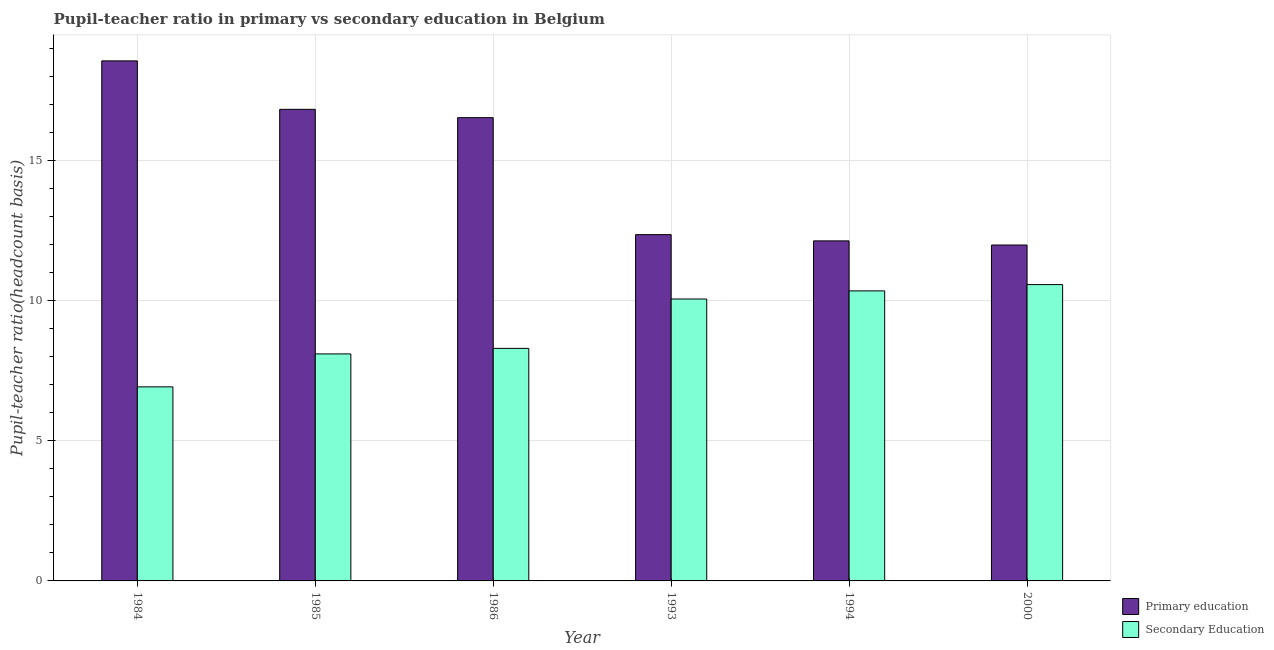How many different coloured bars are there?
Keep it short and to the point. 2. Are the number of bars on each tick of the X-axis equal?
Make the answer very short. Yes. How many bars are there on the 3rd tick from the left?
Your response must be concise. 2. What is the label of the 1st group of bars from the left?
Give a very brief answer. 1984. In how many cases, is the number of bars for a given year not equal to the number of legend labels?
Your answer should be very brief. 0. What is the pupil-teacher ratio in primary education in 1986?
Your answer should be compact. 16.53. Across all years, what is the maximum pupil teacher ratio on secondary education?
Your answer should be compact. 10.57. Across all years, what is the minimum pupil-teacher ratio in primary education?
Ensure brevity in your answer.  11.98. In which year was the pupil-teacher ratio in primary education maximum?
Ensure brevity in your answer.  1984. What is the total pupil teacher ratio on secondary education in the graph?
Provide a succinct answer. 54.29. What is the difference between the pupil teacher ratio on secondary education in 1985 and that in 1986?
Ensure brevity in your answer.  -0.2. What is the difference between the pupil teacher ratio on secondary education in 1985 and the pupil-teacher ratio in primary education in 1993?
Your answer should be compact. -1.96. What is the average pupil teacher ratio on secondary education per year?
Keep it short and to the point. 9.05. In how many years, is the pupil-teacher ratio in primary education greater than 6?
Keep it short and to the point. 6. What is the ratio of the pupil teacher ratio on secondary education in 1985 to that in 1994?
Keep it short and to the point. 0.78. Is the pupil teacher ratio on secondary education in 1985 less than that in 1994?
Keep it short and to the point. Yes. Is the difference between the pupil-teacher ratio in primary education in 1986 and 1994 greater than the difference between the pupil teacher ratio on secondary education in 1986 and 1994?
Your answer should be very brief. No. What is the difference between the highest and the second highest pupil-teacher ratio in primary education?
Your response must be concise. 1.73. What is the difference between the highest and the lowest pupil-teacher ratio in primary education?
Give a very brief answer. 6.57. In how many years, is the pupil-teacher ratio in primary education greater than the average pupil-teacher ratio in primary education taken over all years?
Your answer should be very brief. 3. Is the sum of the pupil-teacher ratio in primary education in 1986 and 1993 greater than the maximum pupil teacher ratio on secondary education across all years?
Your response must be concise. Yes. What does the 2nd bar from the left in 1984 represents?
Your answer should be compact. Secondary Education. Are all the bars in the graph horizontal?
Provide a short and direct response. No. How many years are there in the graph?
Give a very brief answer. 6. Are the values on the major ticks of Y-axis written in scientific E-notation?
Offer a very short reply. No. Does the graph contain grids?
Keep it short and to the point. Yes. How many legend labels are there?
Provide a short and direct response. 2. What is the title of the graph?
Provide a succinct answer. Pupil-teacher ratio in primary vs secondary education in Belgium. Does "Current US$" appear as one of the legend labels in the graph?
Make the answer very short. No. What is the label or title of the Y-axis?
Make the answer very short. Pupil-teacher ratio(headcount basis). What is the Pupil-teacher ratio(headcount basis) in Primary education in 1984?
Ensure brevity in your answer.  18.55. What is the Pupil-teacher ratio(headcount basis) of Secondary Education in 1984?
Make the answer very short. 6.92. What is the Pupil-teacher ratio(headcount basis) of Primary education in 1985?
Offer a terse response. 16.82. What is the Pupil-teacher ratio(headcount basis) in Secondary Education in 1985?
Provide a short and direct response. 8.1. What is the Pupil-teacher ratio(headcount basis) of Primary education in 1986?
Offer a very short reply. 16.53. What is the Pupil-teacher ratio(headcount basis) in Secondary Education in 1986?
Provide a short and direct response. 8.3. What is the Pupil-teacher ratio(headcount basis) in Primary education in 1993?
Your answer should be very brief. 12.35. What is the Pupil-teacher ratio(headcount basis) of Secondary Education in 1993?
Provide a succinct answer. 10.06. What is the Pupil-teacher ratio(headcount basis) in Primary education in 1994?
Offer a terse response. 12.13. What is the Pupil-teacher ratio(headcount basis) of Secondary Education in 1994?
Keep it short and to the point. 10.35. What is the Pupil-teacher ratio(headcount basis) in Primary education in 2000?
Your response must be concise. 11.98. What is the Pupil-teacher ratio(headcount basis) in Secondary Education in 2000?
Keep it short and to the point. 10.57. Across all years, what is the maximum Pupil-teacher ratio(headcount basis) in Primary education?
Your answer should be compact. 18.55. Across all years, what is the maximum Pupil-teacher ratio(headcount basis) of Secondary Education?
Your answer should be very brief. 10.57. Across all years, what is the minimum Pupil-teacher ratio(headcount basis) of Primary education?
Your answer should be compact. 11.98. Across all years, what is the minimum Pupil-teacher ratio(headcount basis) in Secondary Education?
Ensure brevity in your answer.  6.92. What is the total Pupil-teacher ratio(headcount basis) of Primary education in the graph?
Offer a very short reply. 88.37. What is the total Pupil-teacher ratio(headcount basis) of Secondary Education in the graph?
Offer a terse response. 54.29. What is the difference between the Pupil-teacher ratio(headcount basis) in Primary education in 1984 and that in 1985?
Your answer should be compact. 1.73. What is the difference between the Pupil-teacher ratio(headcount basis) in Secondary Education in 1984 and that in 1985?
Give a very brief answer. -1.18. What is the difference between the Pupil-teacher ratio(headcount basis) in Primary education in 1984 and that in 1986?
Your answer should be compact. 2.03. What is the difference between the Pupil-teacher ratio(headcount basis) of Secondary Education in 1984 and that in 1986?
Your answer should be very brief. -1.37. What is the difference between the Pupil-teacher ratio(headcount basis) in Primary education in 1984 and that in 1993?
Offer a terse response. 6.2. What is the difference between the Pupil-teacher ratio(headcount basis) in Secondary Education in 1984 and that in 1993?
Provide a succinct answer. -3.13. What is the difference between the Pupil-teacher ratio(headcount basis) in Primary education in 1984 and that in 1994?
Give a very brief answer. 6.42. What is the difference between the Pupil-teacher ratio(headcount basis) in Secondary Education in 1984 and that in 1994?
Your answer should be very brief. -3.42. What is the difference between the Pupil-teacher ratio(headcount basis) in Primary education in 1984 and that in 2000?
Ensure brevity in your answer.  6.57. What is the difference between the Pupil-teacher ratio(headcount basis) in Secondary Education in 1984 and that in 2000?
Keep it short and to the point. -3.65. What is the difference between the Pupil-teacher ratio(headcount basis) in Primary education in 1985 and that in 1986?
Keep it short and to the point. 0.3. What is the difference between the Pupil-teacher ratio(headcount basis) of Secondary Education in 1985 and that in 1986?
Give a very brief answer. -0.2. What is the difference between the Pupil-teacher ratio(headcount basis) in Primary education in 1985 and that in 1993?
Ensure brevity in your answer.  4.47. What is the difference between the Pupil-teacher ratio(headcount basis) of Secondary Education in 1985 and that in 1993?
Your response must be concise. -1.96. What is the difference between the Pupil-teacher ratio(headcount basis) of Primary education in 1985 and that in 1994?
Keep it short and to the point. 4.69. What is the difference between the Pupil-teacher ratio(headcount basis) of Secondary Education in 1985 and that in 1994?
Offer a very short reply. -2.25. What is the difference between the Pupil-teacher ratio(headcount basis) in Primary education in 1985 and that in 2000?
Make the answer very short. 4.84. What is the difference between the Pupil-teacher ratio(headcount basis) in Secondary Education in 1985 and that in 2000?
Ensure brevity in your answer.  -2.47. What is the difference between the Pupil-teacher ratio(headcount basis) in Primary education in 1986 and that in 1993?
Your answer should be compact. 4.17. What is the difference between the Pupil-teacher ratio(headcount basis) in Secondary Education in 1986 and that in 1993?
Your answer should be very brief. -1.76. What is the difference between the Pupil-teacher ratio(headcount basis) in Primary education in 1986 and that in 1994?
Make the answer very short. 4.4. What is the difference between the Pupil-teacher ratio(headcount basis) of Secondary Education in 1986 and that in 1994?
Offer a very short reply. -2.05. What is the difference between the Pupil-teacher ratio(headcount basis) of Primary education in 1986 and that in 2000?
Your answer should be compact. 4.54. What is the difference between the Pupil-teacher ratio(headcount basis) of Secondary Education in 1986 and that in 2000?
Offer a very short reply. -2.27. What is the difference between the Pupil-teacher ratio(headcount basis) in Primary education in 1993 and that in 1994?
Your response must be concise. 0.22. What is the difference between the Pupil-teacher ratio(headcount basis) in Secondary Education in 1993 and that in 1994?
Your response must be concise. -0.29. What is the difference between the Pupil-teacher ratio(headcount basis) in Primary education in 1993 and that in 2000?
Your response must be concise. 0.37. What is the difference between the Pupil-teacher ratio(headcount basis) of Secondary Education in 1993 and that in 2000?
Offer a very short reply. -0.51. What is the difference between the Pupil-teacher ratio(headcount basis) in Primary education in 1994 and that in 2000?
Your answer should be very brief. 0.15. What is the difference between the Pupil-teacher ratio(headcount basis) in Secondary Education in 1994 and that in 2000?
Offer a terse response. -0.22. What is the difference between the Pupil-teacher ratio(headcount basis) of Primary education in 1984 and the Pupil-teacher ratio(headcount basis) of Secondary Education in 1985?
Provide a succinct answer. 10.45. What is the difference between the Pupil-teacher ratio(headcount basis) of Primary education in 1984 and the Pupil-teacher ratio(headcount basis) of Secondary Education in 1986?
Give a very brief answer. 10.26. What is the difference between the Pupil-teacher ratio(headcount basis) in Primary education in 1984 and the Pupil-teacher ratio(headcount basis) in Secondary Education in 1993?
Your answer should be compact. 8.49. What is the difference between the Pupil-teacher ratio(headcount basis) of Primary education in 1984 and the Pupil-teacher ratio(headcount basis) of Secondary Education in 1994?
Keep it short and to the point. 8.21. What is the difference between the Pupil-teacher ratio(headcount basis) in Primary education in 1984 and the Pupil-teacher ratio(headcount basis) in Secondary Education in 2000?
Offer a very short reply. 7.98. What is the difference between the Pupil-teacher ratio(headcount basis) in Primary education in 1985 and the Pupil-teacher ratio(headcount basis) in Secondary Education in 1986?
Provide a succinct answer. 8.53. What is the difference between the Pupil-teacher ratio(headcount basis) of Primary education in 1985 and the Pupil-teacher ratio(headcount basis) of Secondary Education in 1993?
Provide a succinct answer. 6.77. What is the difference between the Pupil-teacher ratio(headcount basis) of Primary education in 1985 and the Pupil-teacher ratio(headcount basis) of Secondary Education in 1994?
Make the answer very short. 6.48. What is the difference between the Pupil-teacher ratio(headcount basis) in Primary education in 1985 and the Pupil-teacher ratio(headcount basis) in Secondary Education in 2000?
Offer a terse response. 6.25. What is the difference between the Pupil-teacher ratio(headcount basis) of Primary education in 1986 and the Pupil-teacher ratio(headcount basis) of Secondary Education in 1993?
Provide a succinct answer. 6.47. What is the difference between the Pupil-teacher ratio(headcount basis) of Primary education in 1986 and the Pupil-teacher ratio(headcount basis) of Secondary Education in 1994?
Your answer should be compact. 6.18. What is the difference between the Pupil-teacher ratio(headcount basis) of Primary education in 1986 and the Pupil-teacher ratio(headcount basis) of Secondary Education in 2000?
Give a very brief answer. 5.95. What is the difference between the Pupil-teacher ratio(headcount basis) in Primary education in 1993 and the Pupil-teacher ratio(headcount basis) in Secondary Education in 1994?
Your answer should be very brief. 2.01. What is the difference between the Pupil-teacher ratio(headcount basis) in Primary education in 1993 and the Pupil-teacher ratio(headcount basis) in Secondary Education in 2000?
Offer a terse response. 1.78. What is the difference between the Pupil-teacher ratio(headcount basis) in Primary education in 1994 and the Pupil-teacher ratio(headcount basis) in Secondary Education in 2000?
Offer a terse response. 1.56. What is the average Pupil-teacher ratio(headcount basis) of Primary education per year?
Ensure brevity in your answer.  14.73. What is the average Pupil-teacher ratio(headcount basis) of Secondary Education per year?
Ensure brevity in your answer.  9.05. In the year 1984, what is the difference between the Pupil-teacher ratio(headcount basis) in Primary education and Pupil-teacher ratio(headcount basis) in Secondary Education?
Give a very brief answer. 11.63. In the year 1985, what is the difference between the Pupil-teacher ratio(headcount basis) in Primary education and Pupil-teacher ratio(headcount basis) in Secondary Education?
Keep it short and to the point. 8.73. In the year 1986, what is the difference between the Pupil-teacher ratio(headcount basis) in Primary education and Pupil-teacher ratio(headcount basis) in Secondary Education?
Keep it short and to the point. 8.23. In the year 1993, what is the difference between the Pupil-teacher ratio(headcount basis) of Primary education and Pupil-teacher ratio(headcount basis) of Secondary Education?
Give a very brief answer. 2.3. In the year 1994, what is the difference between the Pupil-teacher ratio(headcount basis) of Primary education and Pupil-teacher ratio(headcount basis) of Secondary Education?
Make the answer very short. 1.78. In the year 2000, what is the difference between the Pupil-teacher ratio(headcount basis) in Primary education and Pupil-teacher ratio(headcount basis) in Secondary Education?
Give a very brief answer. 1.41. What is the ratio of the Pupil-teacher ratio(headcount basis) in Primary education in 1984 to that in 1985?
Provide a succinct answer. 1.1. What is the ratio of the Pupil-teacher ratio(headcount basis) of Secondary Education in 1984 to that in 1985?
Offer a very short reply. 0.85. What is the ratio of the Pupil-teacher ratio(headcount basis) in Primary education in 1984 to that in 1986?
Provide a short and direct response. 1.12. What is the ratio of the Pupil-teacher ratio(headcount basis) in Secondary Education in 1984 to that in 1986?
Give a very brief answer. 0.83. What is the ratio of the Pupil-teacher ratio(headcount basis) of Primary education in 1984 to that in 1993?
Offer a very short reply. 1.5. What is the ratio of the Pupil-teacher ratio(headcount basis) of Secondary Education in 1984 to that in 1993?
Make the answer very short. 0.69. What is the ratio of the Pupil-teacher ratio(headcount basis) of Primary education in 1984 to that in 1994?
Ensure brevity in your answer.  1.53. What is the ratio of the Pupil-teacher ratio(headcount basis) in Secondary Education in 1984 to that in 1994?
Ensure brevity in your answer.  0.67. What is the ratio of the Pupil-teacher ratio(headcount basis) in Primary education in 1984 to that in 2000?
Provide a succinct answer. 1.55. What is the ratio of the Pupil-teacher ratio(headcount basis) of Secondary Education in 1984 to that in 2000?
Give a very brief answer. 0.65. What is the ratio of the Pupil-teacher ratio(headcount basis) in Secondary Education in 1985 to that in 1986?
Keep it short and to the point. 0.98. What is the ratio of the Pupil-teacher ratio(headcount basis) of Primary education in 1985 to that in 1993?
Your answer should be compact. 1.36. What is the ratio of the Pupil-teacher ratio(headcount basis) of Secondary Education in 1985 to that in 1993?
Provide a short and direct response. 0.81. What is the ratio of the Pupil-teacher ratio(headcount basis) in Primary education in 1985 to that in 1994?
Provide a short and direct response. 1.39. What is the ratio of the Pupil-teacher ratio(headcount basis) in Secondary Education in 1985 to that in 1994?
Give a very brief answer. 0.78. What is the ratio of the Pupil-teacher ratio(headcount basis) in Primary education in 1985 to that in 2000?
Ensure brevity in your answer.  1.4. What is the ratio of the Pupil-teacher ratio(headcount basis) in Secondary Education in 1985 to that in 2000?
Give a very brief answer. 0.77. What is the ratio of the Pupil-teacher ratio(headcount basis) in Primary education in 1986 to that in 1993?
Ensure brevity in your answer.  1.34. What is the ratio of the Pupil-teacher ratio(headcount basis) in Secondary Education in 1986 to that in 1993?
Offer a very short reply. 0.82. What is the ratio of the Pupil-teacher ratio(headcount basis) of Primary education in 1986 to that in 1994?
Provide a short and direct response. 1.36. What is the ratio of the Pupil-teacher ratio(headcount basis) in Secondary Education in 1986 to that in 1994?
Make the answer very short. 0.8. What is the ratio of the Pupil-teacher ratio(headcount basis) of Primary education in 1986 to that in 2000?
Ensure brevity in your answer.  1.38. What is the ratio of the Pupil-teacher ratio(headcount basis) of Secondary Education in 1986 to that in 2000?
Offer a terse response. 0.78. What is the ratio of the Pupil-teacher ratio(headcount basis) of Primary education in 1993 to that in 1994?
Your response must be concise. 1.02. What is the ratio of the Pupil-teacher ratio(headcount basis) in Secondary Education in 1993 to that in 1994?
Your answer should be very brief. 0.97. What is the ratio of the Pupil-teacher ratio(headcount basis) in Primary education in 1993 to that in 2000?
Keep it short and to the point. 1.03. What is the ratio of the Pupil-teacher ratio(headcount basis) in Secondary Education in 1993 to that in 2000?
Offer a terse response. 0.95. What is the ratio of the Pupil-teacher ratio(headcount basis) of Primary education in 1994 to that in 2000?
Make the answer very short. 1.01. What is the ratio of the Pupil-teacher ratio(headcount basis) in Secondary Education in 1994 to that in 2000?
Provide a short and direct response. 0.98. What is the difference between the highest and the second highest Pupil-teacher ratio(headcount basis) in Primary education?
Provide a succinct answer. 1.73. What is the difference between the highest and the second highest Pupil-teacher ratio(headcount basis) in Secondary Education?
Your answer should be compact. 0.22. What is the difference between the highest and the lowest Pupil-teacher ratio(headcount basis) in Primary education?
Ensure brevity in your answer.  6.57. What is the difference between the highest and the lowest Pupil-teacher ratio(headcount basis) of Secondary Education?
Your answer should be compact. 3.65. 